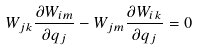Convert formula to latex. <formula><loc_0><loc_0><loc_500><loc_500>W _ { j k } \frac { \partial W _ { i m } } { \partial q _ { j } } - W _ { j m } \frac { \partial W _ { i k } } { \partial q _ { j } } = 0</formula> 